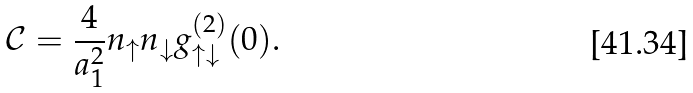Convert formula to latex. <formula><loc_0><loc_0><loc_500><loc_500>\mathcal { C } = \frac { 4 } { a _ { 1 } ^ { 2 } } n _ { \uparrow } n _ { \downarrow } g _ { \uparrow \downarrow } ^ { ( 2 ) } ( 0 ) .</formula> 